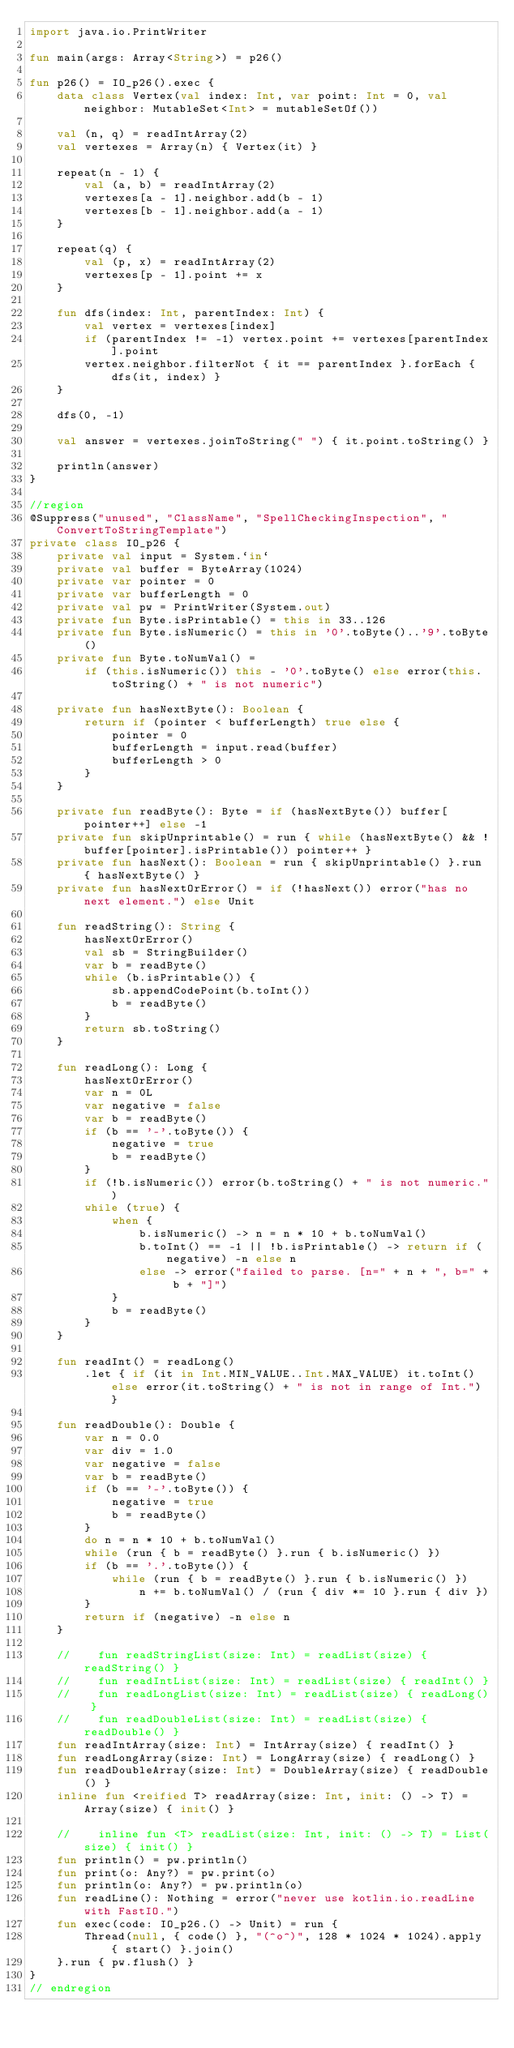Convert code to text. <code><loc_0><loc_0><loc_500><loc_500><_Kotlin_>import java.io.PrintWriter

fun main(args: Array<String>) = p26()

fun p26() = IO_p26().exec {
    data class Vertex(val index: Int, var point: Int = 0, val neighbor: MutableSet<Int> = mutableSetOf())

    val (n, q) = readIntArray(2)
    val vertexes = Array(n) { Vertex(it) }

    repeat(n - 1) {
        val (a, b) = readIntArray(2)
        vertexes[a - 1].neighbor.add(b - 1)
        vertexes[b - 1].neighbor.add(a - 1)
    }

    repeat(q) {
        val (p, x) = readIntArray(2)
        vertexes[p - 1].point += x
    }

    fun dfs(index: Int, parentIndex: Int) {
        val vertex = vertexes[index]
        if (parentIndex != -1) vertex.point += vertexes[parentIndex].point
        vertex.neighbor.filterNot { it == parentIndex }.forEach { dfs(it, index) }
    }

    dfs(0, -1)

    val answer = vertexes.joinToString(" ") { it.point.toString() }

    println(answer)
}

//region
@Suppress("unused", "ClassName", "SpellCheckingInspection", "ConvertToStringTemplate")
private class IO_p26 {
    private val input = System.`in`
    private val buffer = ByteArray(1024)
    private var pointer = 0
    private var bufferLength = 0
    private val pw = PrintWriter(System.out)
    private fun Byte.isPrintable() = this in 33..126
    private fun Byte.isNumeric() = this in '0'.toByte()..'9'.toByte()
    private fun Byte.toNumVal() =
        if (this.isNumeric()) this - '0'.toByte() else error(this.toString() + " is not numeric")

    private fun hasNextByte(): Boolean {
        return if (pointer < bufferLength) true else {
            pointer = 0
            bufferLength = input.read(buffer)
            bufferLength > 0
        }
    }

    private fun readByte(): Byte = if (hasNextByte()) buffer[pointer++] else -1
    private fun skipUnprintable() = run { while (hasNextByte() && !buffer[pointer].isPrintable()) pointer++ }
    private fun hasNext(): Boolean = run { skipUnprintable() }.run { hasNextByte() }
    private fun hasNextOrError() = if (!hasNext()) error("has no next element.") else Unit

    fun readString(): String {
        hasNextOrError()
        val sb = StringBuilder()
        var b = readByte()
        while (b.isPrintable()) {
            sb.appendCodePoint(b.toInt())
            b = readByte()
        }
        return sb.toString()
    }

    fun readLong(): Long {
        hasNextOrError()
        var n = 0L
        var negative = false
        var b = readByte()
        if (b == '-'.toByte()) {
            negative = true
            b = readByte()
        }
        if (!b.isNumeric()) error(b.toString() + " is not numeric.")
        while (true) {
            when {
                b.isNumeric() -> n = n * 10 + b.toNumVal()
                b.toInt() == -1 || !b.isPrintable() -> return if (negative) -n else n
                else -> error("failed to parse. [n=" + n + ", b=" + b + "]")
            }
            b = readByte()
        }
    }

    fun readInt() = readLong()
        .let { if (it in Int.MIN_VALUE..Int.MAX_VALUE) it.toInt() else error(it.toString() + " is not in range of Int.") }

    fun readDouble(): Double {
        var n = 0.0
        var div = 1.0
        var negative = false
        var b = readByte()
        if (b == '-'.toByte()) {
            negative = true
            b = readByte()
        }
        do n = n * 10 + b.toNumVal()
        while (run { b = readByte() }.run { b.isNumeric() })
        if (b == '.'.toByte()) {
            while (run { b = readByte() }.run { b.isNumeric() })
                n += b.toNumVal() / (run { div *= 10 }.run { div })
        }
        return if (negative) -n else n
    }

    //    fun readStringList(size: Int) = readList(size) { readString() }
    //    fun readIntList(size: Int) = readList(size) { readInt() }
    //    fun readLongList(size: Int) = readList(size) { readLong() }
    //    fun readDoubleList(size: Int) = readList(size) { readDouble() }
    fun readIntArray(size: Int) = IntArray(size) { readInt() }
    fun readLongArray(size: Int) = LongArray(size) { readLong() }
    fun readDoubleArray(size: Int) = DoubleArray(size) { readDouble() }
    inline fun <reified T> readArray(size: Int, init: () -> T) = Array(size) { init() }

    //    inline fun <T> readList(size: Int, init: () -> T) = List(size) { init() }
    fun println() = pw.println()
    fun print(o: Any?) = pw.print(o)
    fun println(o: Any?) = pw.println(o)
    fun readLine(): Nothing = error("never use kotlin.io.readLine with FastIO.")
    fun exec(code: IO_p26.() -> Unit) = run {
        Thread(null, { code() }, "(^o^)", 128 * 1024 * 1024).apply { start() }.join()
    }.run { pw.flush() }
}
// endregion
</code> 